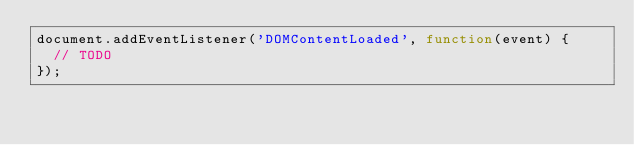<code> <loc_0><loc_0><loc_500><loc_500><_JavaScript_>document.addEventListener('DOMContentLoaded', function(event) {
  // TODO
});
</code> 